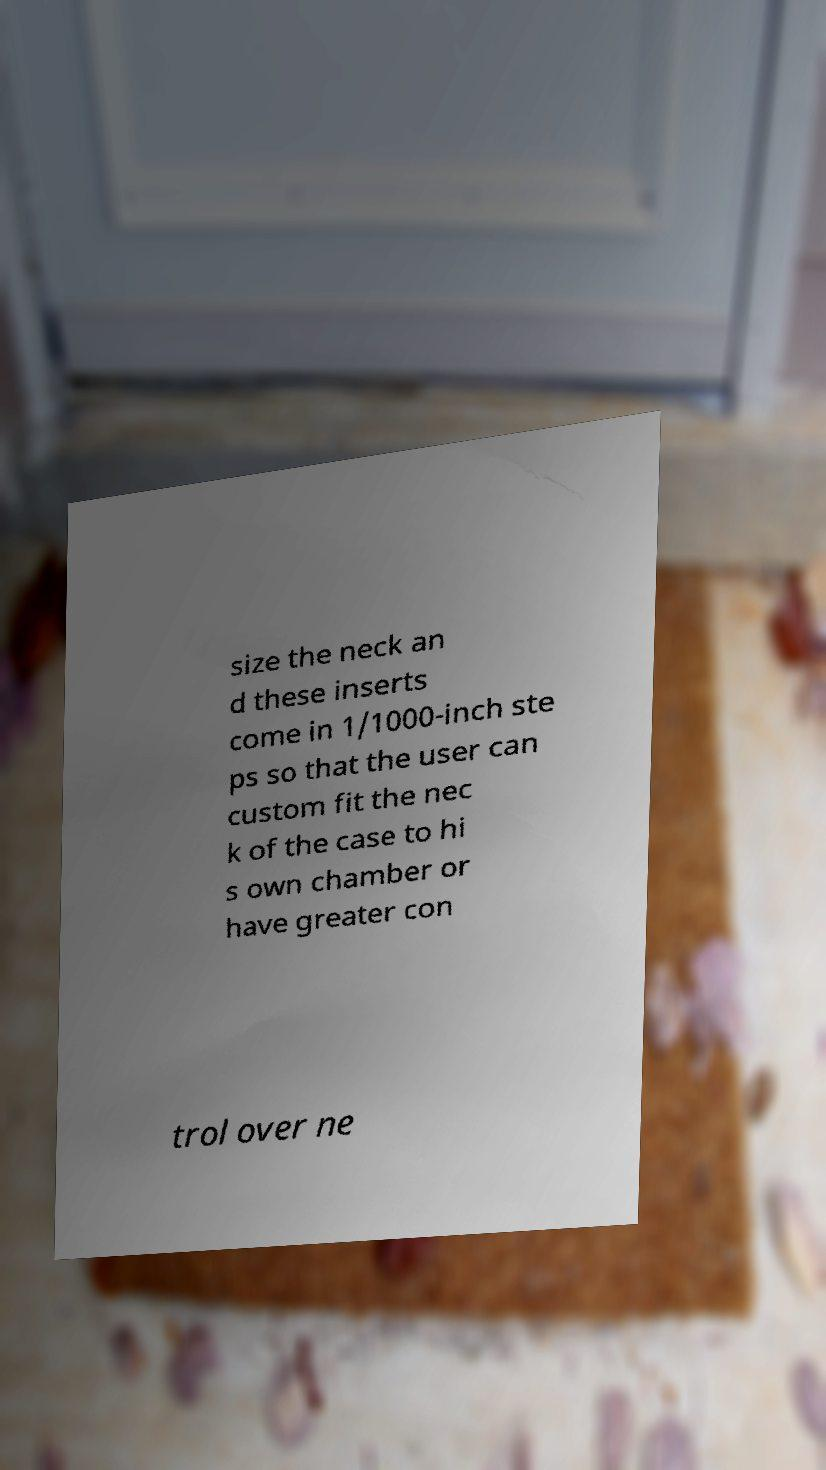What messages or text are displayed in this image? I need them in a readable, typed format. size the neck an d these inserts come in 1/1000-inch ste ps so that the user can custom fit the nec k of the case to hi s own chamber or have greater con trol over ne 